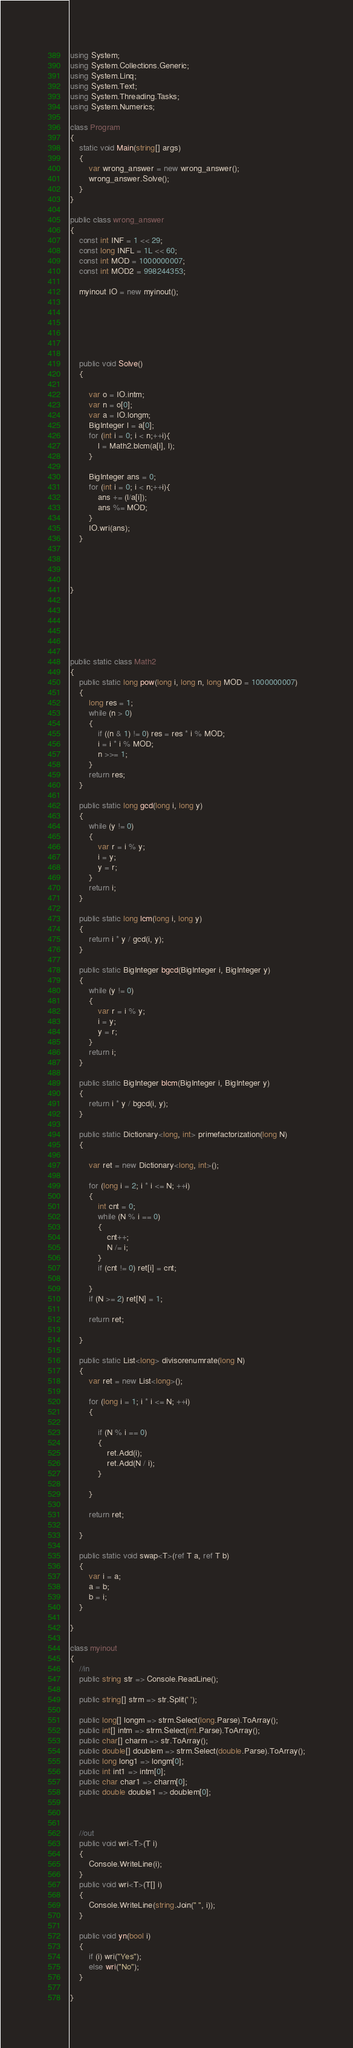<code> <loc_0><loc_0><loc_500><loc_500><_C#_>using System;
using System.Collections.Generic;
using System.Linq;
using System.Text;
using System.Threading.Tasks;
using System.Numerics;

class Program
{
    static void Main(string[] args)
    {
        var wrong_answer = new wrong_answer();
        wrong_answer.Solve();
    }
}

public class wrong_answer
{
    const int INF = 1 << 29;
    const long INFL = 1L << 60;
    const int MOD = 1000000007;
    const int MOD2 = 998244353;

    myinout IO = new myinout();






    public void Solve()
    {

        var o = IO.intm;
        var n = o[0];
        var a = IO.longm;
        BigInteger l = a[0];
        for (int i = 0; i < n;++i){
            l = Math2.blcm(a[i], l);
        }

        BigInteger ans = 0;
        for (int i = 0; i < n;++i){
            ans += (l/a[i]);
            ans %= MOD;
        }
        IO.wri(ans);
    }




}






public static class Math2
{
    public static long pow(long i, long n, long MOD = 1000000007)
    {
        long res = 1;
        while (n > 0)
        {
            if ((n & 1) != 0) res = res * i % MOD;
            i = i * i % MOD;
            n >>= 1;
        }
        return res;
    }

    public static long gcd(long i, long y)
    {
        while (y != 0)
        {
            var r = i % y;
            i = y;
            y = r;
        }
        return i;
    }

    public static long lcm(long i, long y)
    {
        return i * y / gcd(i, y);
    }

    public static BigInteger bgcd(BigInteger i, BigInteger y)
    {
        while (y != 0)
        {
            var r = i % y;
            i = y;
            y = r;
        }
        return i;
    }

    public static BigInteger blcm(BigInteger i, BigInteger y)
    {
        return i * y / bgcd(i, y);
    }

    public static Dictionary<long, int> primefactorization(long N)
    {

        var ret = new Dictionary<long, int>();

        for (long i = 2; i * i <= N; ++i)
        {
            int cnt = 0;
            while (N % i == 0)
            {
                cnt++;
                N /= i;
            }
            if (cnt != 0) ret[i] = cnt;

        }
        if (N >= 2) ret[N] = 1;

        return ret;

    }

    public static List<long> divisorenumrate(long N)
    {
        var ret = new List<long>();

        for (long i = 1; i * i <= N; ++i)
        {

            if (N % i == 0)
            {
                ret.Add(i);
                ret.Add(N / i);
            }

        }

        return ret;

    }

    public static void swap<T>(ref T a, ref T b)
    {
        var i = a;
        a = b;
        b = i;
    }

}

class myinout
{
    //in
    public string str => Console.ReadLine();

    public string[] strm => str.Split(' ');

    public long[] longm => strm.Select(long.Parse).ToArray();
    public int[] intm => strm.Select(int.Parse).ToArray();
    public char[] charm => str.ToArray();
    public double[] doublem => strm.Select(double.Parse).ToArray();
    public long long1 => longm[0];
    public int int1 => intm[0];
    public char char1 => charm[0];
    public double double1 => doublem[0];



    //out
    public void wri<T>(T i)
    {
        Console.WriteLine(i);
    }
    public void wri<T>(T[] i)
    {
        Console.WriteLine(string.Join(" ", i));
    }

    public void yn(bool i)
    {
        if (i) wri("Yes");
        else wri("No");
    }

}
</code> 